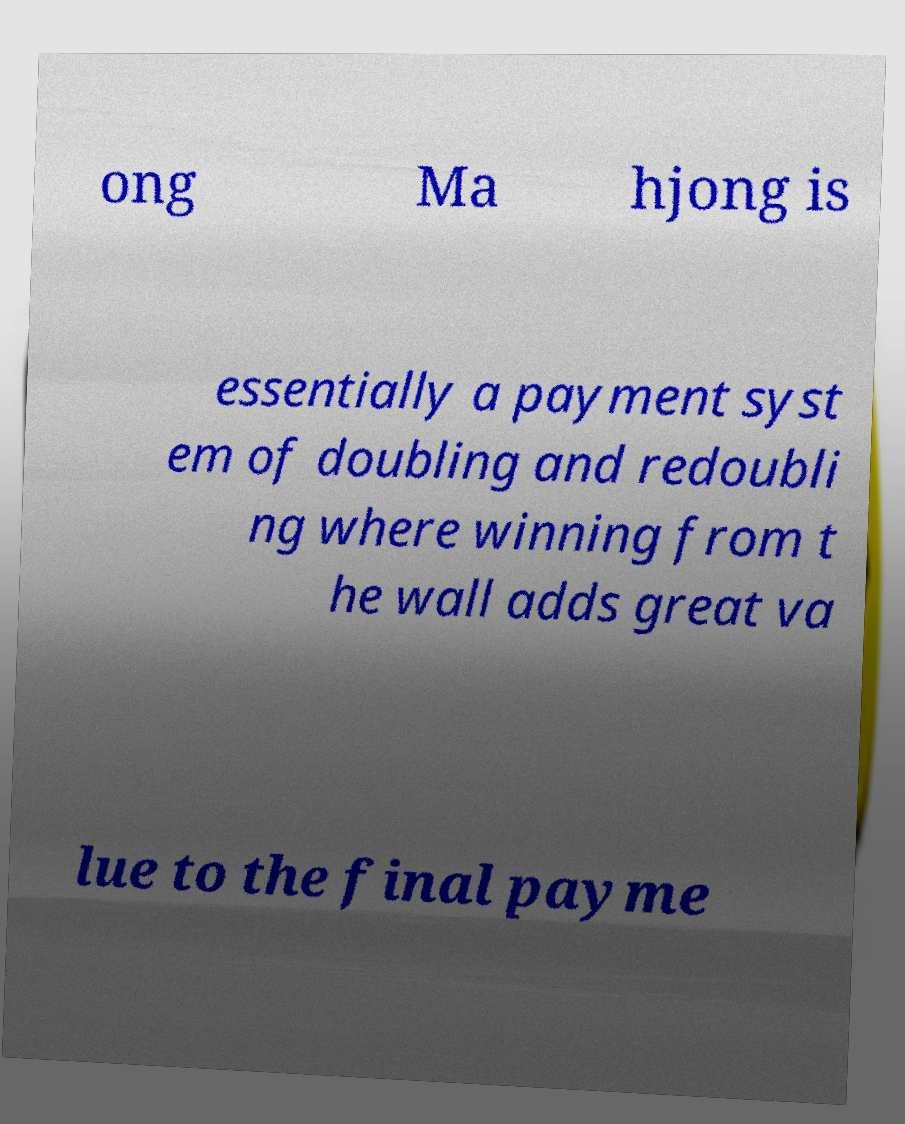What messages or text are displayed in this image? I need them in a readable, typed format. ong Ma hjong is essentially a payment syst em of doubling and redoubli ng where winning from t he wall adds great va lue to the final payme 